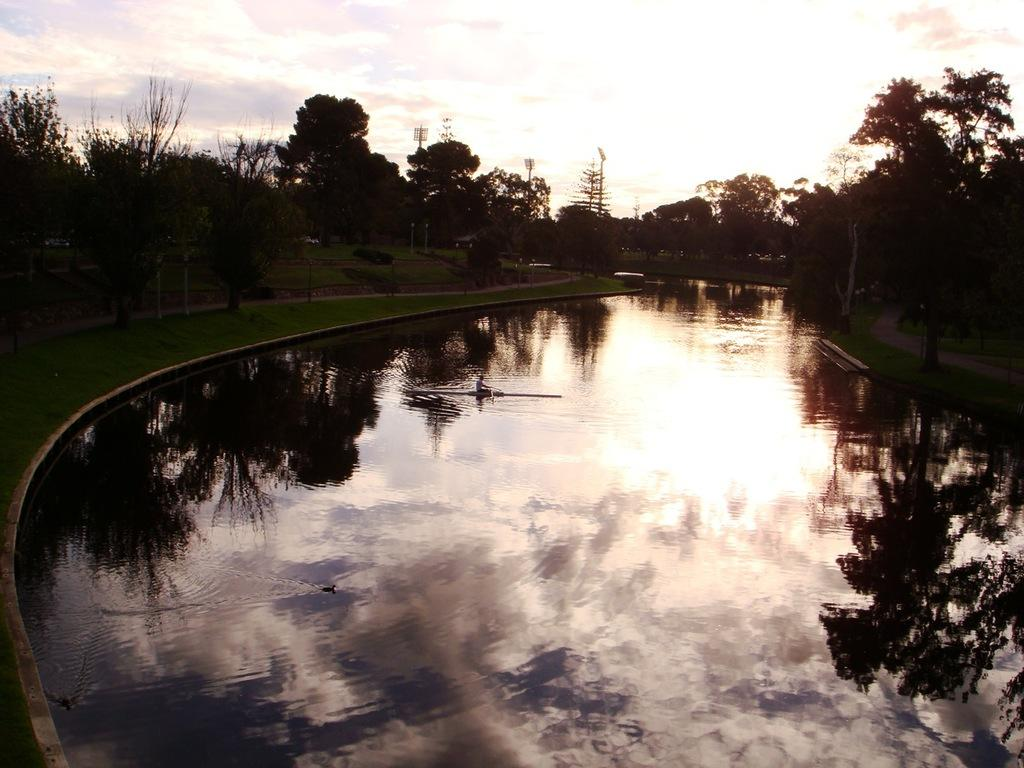What is the main element in the image? There is water in the image. What is happening on the surface of the water? There is a person on the surface of the water. What type of vegetation can be seen in the image? There is grass and trees visible in the image. What can be seen in the background of the image? There is a road, trees, light poles, and the sky visible in the background of the image. What type of beam is holding up the bread in the image? There is no bread or beam present in the image. What type of cable can be seen connecting the trees in the image? There are no cables connecting the trees in the image. 